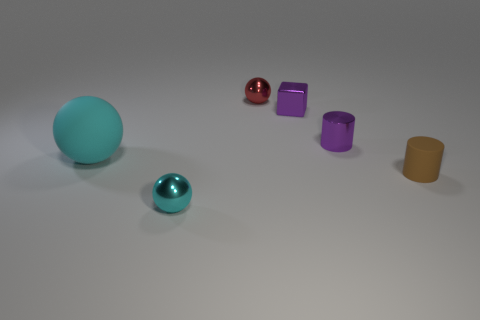Is there any other thing that has the same size as the cyan matte object?
Provide a succinct answer. No. There is another big object that is the same shape as the cyan metal object; what color is it?
Make the answer very short. Cyan. Does the cyan metal object have the same size as the cube?
Ensure brevity in your answer.  Yes. Are there an equal number of small purple blocks on the right side of the brown matte cylinder and balls that are to the left of the small cyan sphere?
Your answer should be very brief. No. Are there any big gray matte objects?
Offer a terse response. No. What size is the red metallic object that is the same shape as the cyan metal object?
Give a very brief answer. Small. How big is the rubber object that is to the left of the tiny purple cylinder?
Ensure brevity in your answer.  Large. Are there more shiny things that are on the right side of the red object than purple cylinders?
Ensure brevity in your answer.  Yes. The big thing has what shape?
Offer a very short reply. Sphere. Do the metal block behind the tiny purple metallic cylinder and the shiny object to the right of the tiny cube have the same color?
Your answer should be very brief. Yes. 